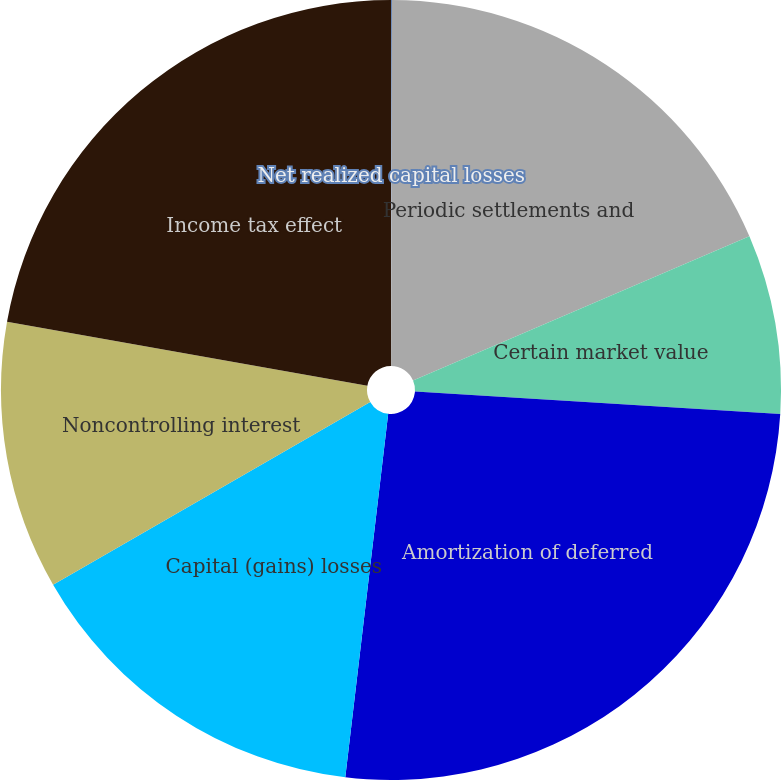Convert chart to OTSL. <chart><loc_0><loc_0><loc_500><loc_500><pie_chart><fcel>Net realized capital losses<fcel>Periodic settlements and<fcel>Certain market value<fcel>Amortization of deferred<fcel>Capital (gains) losses<fcel>Noncontrolling interest<fcel>Income tax effect<nl><fcel>0.04%<fcel>18.51%<fcel>7.43%<fcel>25.89%<fcel>14.81%<fcel>11.12%<fcel>22.2%<nl></chart> 